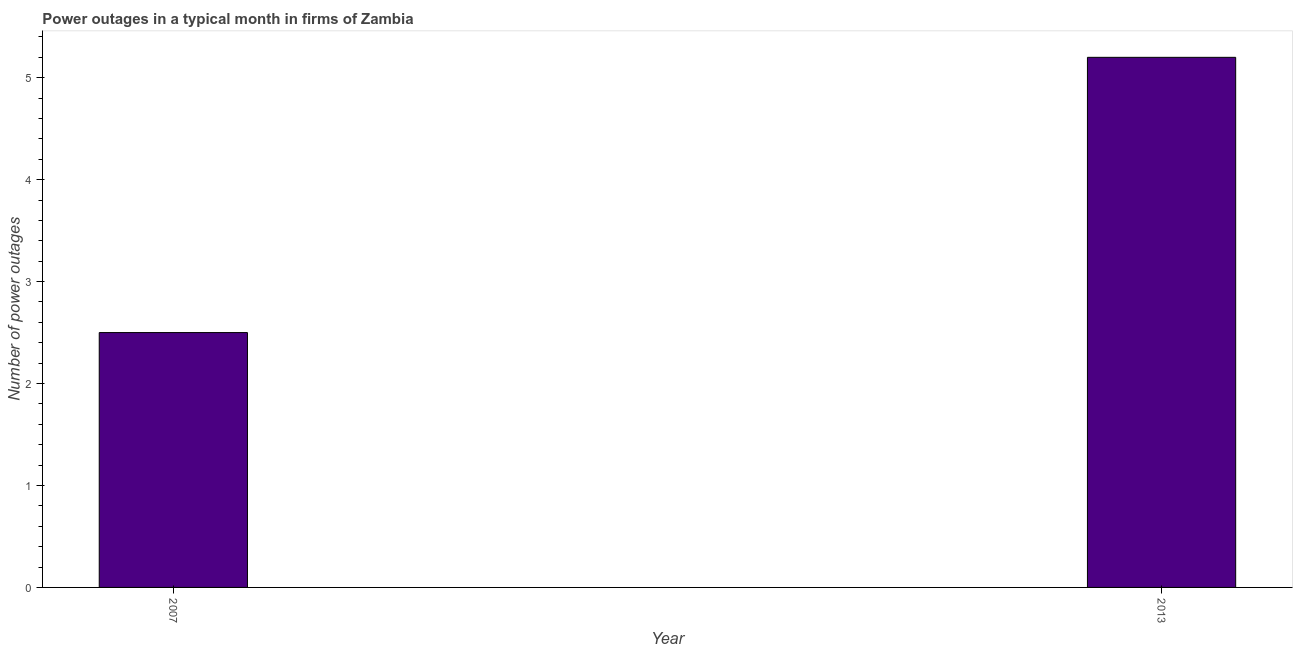Does the graph contain grids?
Make the answer very short. No. What is the title of the graph?
Provide a succinct answer. Power outages in a typical month in firms of Zambia. What is the label or title of the Y-axis?
Offer a terse response. Number of power outages. Across all years, what is the maximum number of power outages?
Offer a very short reply. 5.2. In which year was the number of power outages maximum?
Make the answer very short. 2013. In which year was the number of power outages minimum?
Provide a succinct answer. 2007. What is the difference between the number of power outages in 2007 and 2013?
Make the answer very short. -2.7. What is the average number of power outages per year?
Offer a very short reply. 3.85. What is the median number of power outages?
Give a very brief answer. 3.85. In how many years, is the number of power outages greater than 4 ?
Your answer should be compact. 1. Do a majority of the years between 2007 and 2013 (inclusive) have number of power outages greater than 3.4 ?
Provide a short and direct response. No. What is the ratio of the number of power outages in 2007 to that in 2013?
Provide a succinct answer. 0.48. In how many years, is the number of power outages greater than the average number of power outages taken over all years?
Ensure brevity in your answer.  1. Are all the bars in the graph horizontal?
Provide a short and direct response. No. How many years are there in the graph?
Your answer should be compact. 2. What is the Number of power outages of 2013?
Your response must be concise. 5.2. What is the difference between the Number of power outages in 2007 and 2013?
Your response must be concise. -2.7. What is the ratio of the Number of power outages in 2007 to that in 2013?
Provide a short and direct response. 0.48. 